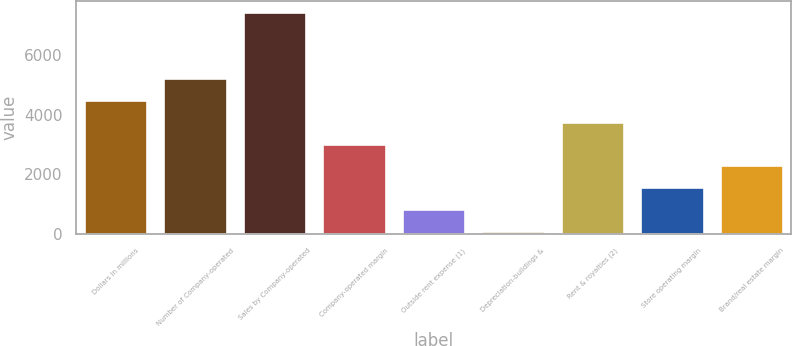Convert chart to OTSL. <chart><loc_0><loc_0><loc_500><loc_500><bar_chart><fcel>Dollars in millions<fcel>Number of Company-operated<fcel>Sales by Company-operated<fcel>Company-operated margin<fcel>Outside rent expense (1)<fcel>Depreciation-buildings &<fcel>Rent & royalties (2)<fcel>Store operating margin<fcel>Brand/real estate margin<nl><fcel>4498.4<fcel>5229.8<fcel>7424<fcel>3035.6<fcel>841.4<fcel>110<fcel>3767<fcel>1572.8<fcel>2304.2<nl></chart> 